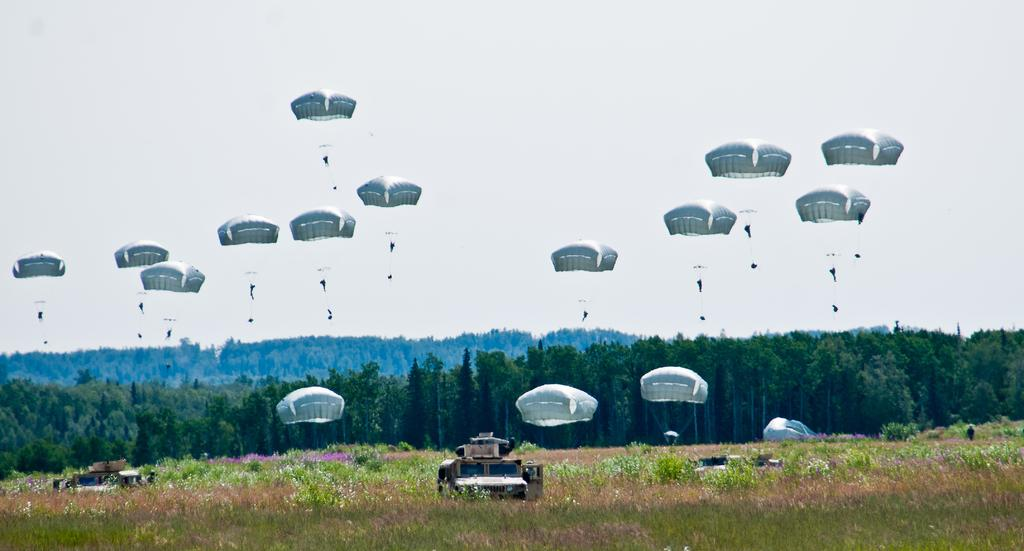What can be seen in the image? There are vehicles in the image. Where are the vehicles located? The vehicles are on a grassland. What else can be seen in the image besides the vehicles? There are plants, trees in the background, and the sky visible in the background. What activity is taking place in the image? There are people parachuting in the image. What type of wheel is being discussed by the plants in the image? There are no plants discussing anything in the image, and therefore no wheel is being discussed. 